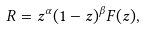Convert formula to latex. <formula><loc_0><loc_0><loc_500><loc_500>R = z ^ { \alpha } ( 1 - z ) ^ { \beta } F ( z ) ,</formula> 